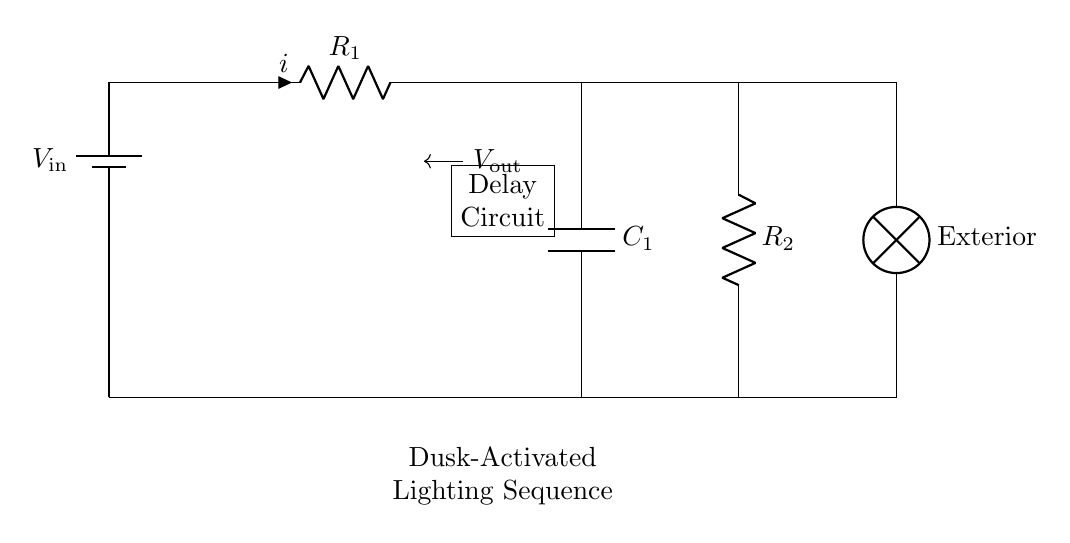What is the component to limit current? The component that limits current in the circuit is a resistor, and in the diagram, it is labelled as R1 and R2.
Answer: Resistor What is the total resistance in the circuit? The total resistance is the sum of R1 and R2, as they are in series in the circuit. The total resistance can be calculated as R1 + R2.
Answer: R1 + R2 What does the capacitor in the circuit do? The capacitor stores electrical energy and introduces a delay in the circuit, affecting how quickly the lighting activates after dusk.
Answer: Delays activation What is the purpose of the battery in the circuit? The battery provides the necessary voltage to power the circuit and activate the components, including the lighting and delay circuit.
Answer: Power source Which component indicates the exterior lighting? The component indicating exterior lighting is the lamp, denoted in the diagram, which illuminates the parking area at dusk.
Answer: Lamp What happens to the output voltage during the charging phase of the capacitor? During the charging phase, the output voltage increases gradually as the capacitor charges, until it reaches a sufficient level to activate the lamp.
Answer: Increases gradually What is the sequence of operation for the exterior lighting? The sequence of operation involves detecting dusk, charging the capacitor, and then activating the lamp after the delay set by the capacitor's discharge time.
Answer: Dusk to activation 